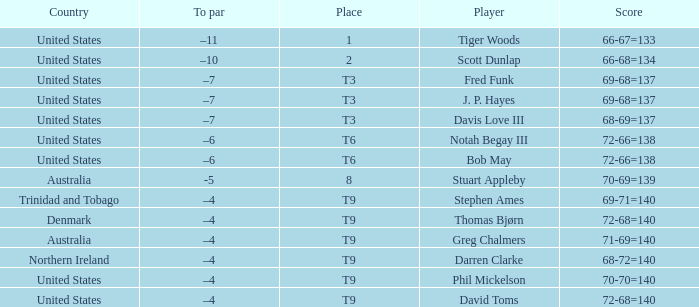What place had a To par of –10? 2.0. 